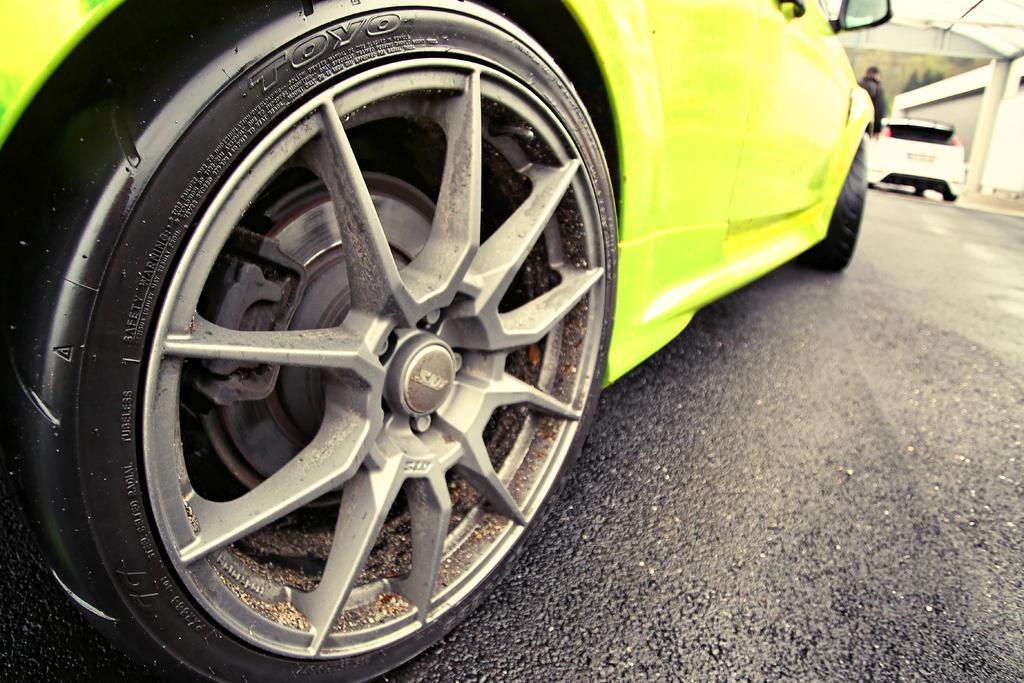What is the main subject in the foreground of the picture? There is a car in the foreground of the picture. Where is the car located? The car is on the road. Can you describe the background of the image? The background of the image is blurred, and there are trees and buildings visible. Are there any other vehicles in the image? Yes, there is at least one other car in the background of the image. Can you identify any people in the image? Yes, there is a person in the background of the image. What type of jam can be seen on the trees in the background of the image? There is no jam present on the trees in the background of the image. How many oranges are visible on the person in the background of the image? There are no oranges visible on the person in the background of the image. 